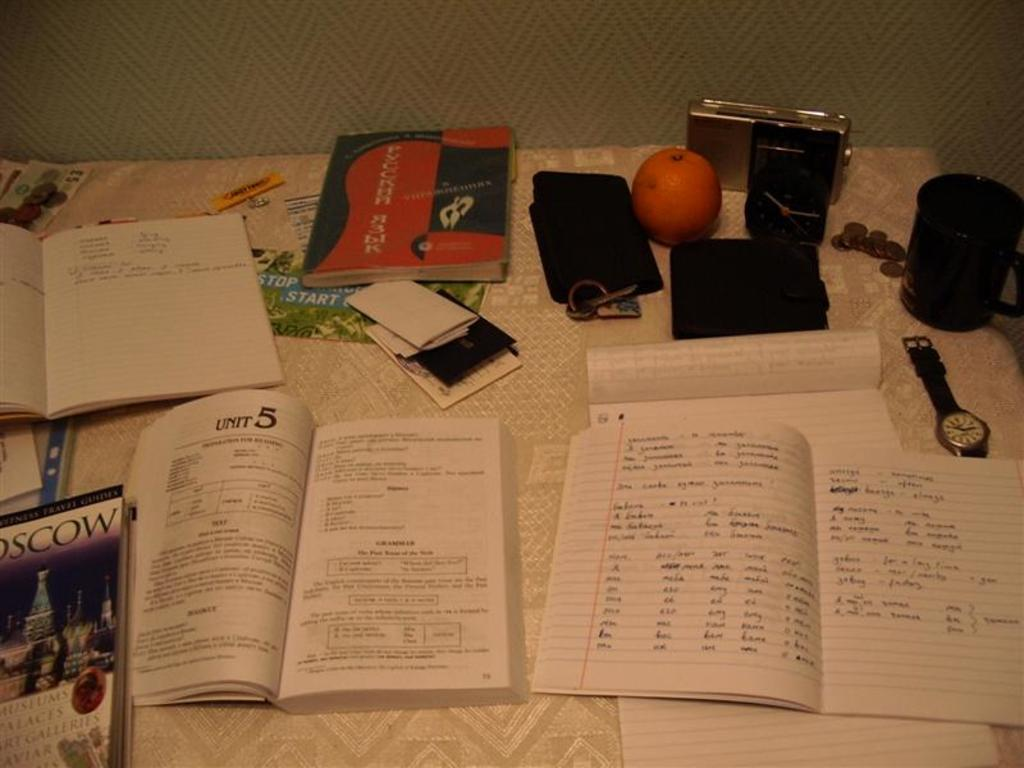Provide a one-sentence caption for the provided image. The book on the table is open to Unit five. 